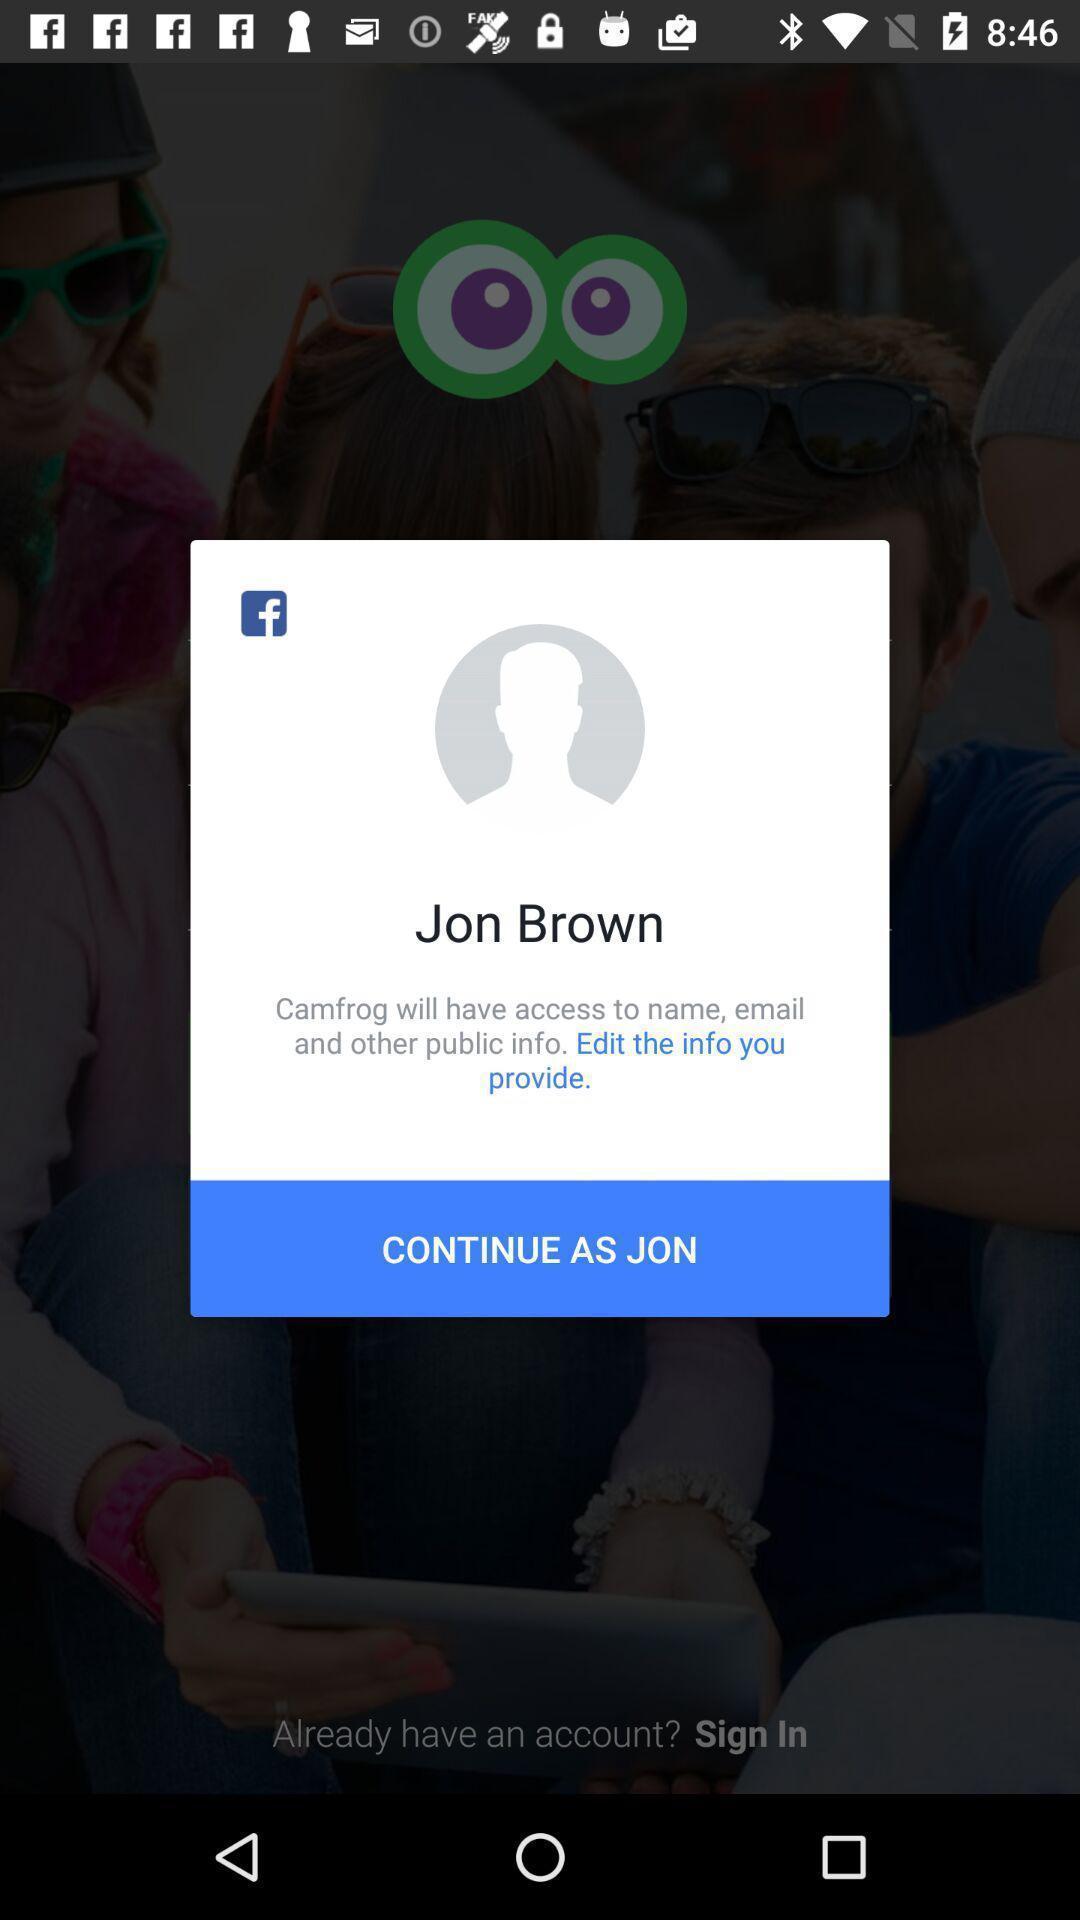Provide a detailed account of this screenshot. Popup of profile to continue with same credentials. 